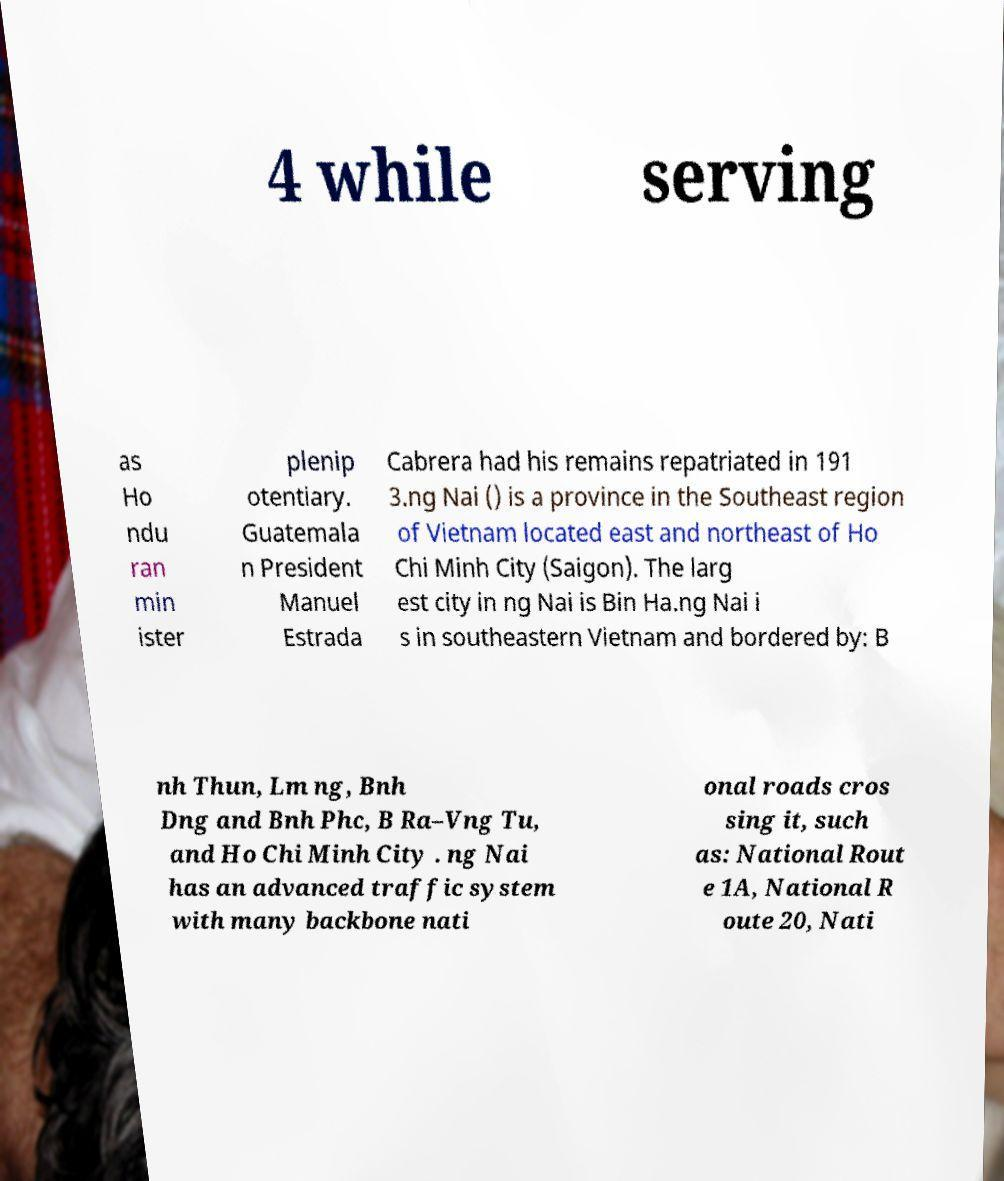What messages or text are displayed in this image? I need them in a readable, typed format. 4 while serving as Ho ndu ran min ister plenip otentiary. Guatemala n President Manuel Estrada Cabrera had his remains repatriated in 191 3.ng Nai () is a province in the Southeast region of Vietnam located east and northeast of Ho Chi Minh City (Saigon). The larg est city in ng Nai is Bin Ha.ng Nai i s in southeastern Vietnam and bordered by: B nh Thun, Lm ng, Bnh Dng and Bnh Phc, B Ra–Vng Tu, and Ho Chi Minh City . ng Nai has an advanced traffic system with many backbone nati onal roads cros sing it, such as: National Rout e 1A, National R oute 20, Nati 